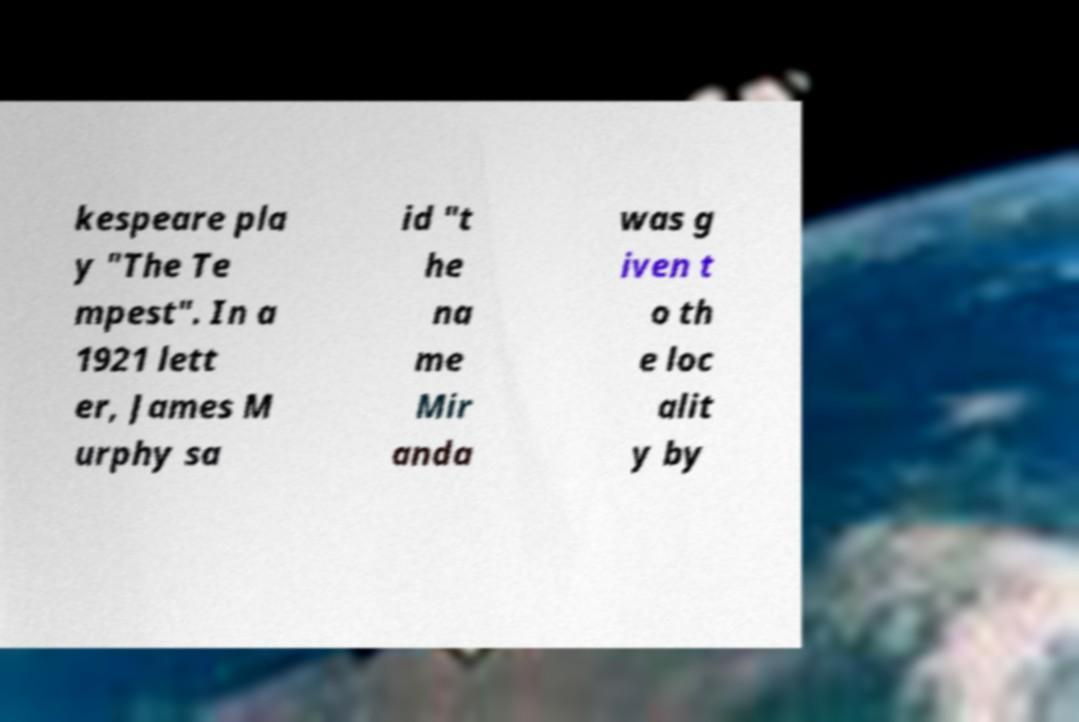Please read and relay the text visible in this image. What does it say? kespeare pla y "The Te mpest". In a 1921 lett er, James M urphy sa id "t he na me Mir anda was g iven t o th e loc alit y by 